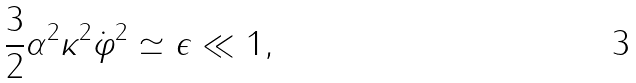<formula> <loc_0><loc_0><loc_500><loc_500>\frac { 3 } { 2 } \alpha ^ { 2 } \kappa ^ { 2 } \dot { \varphi } ^ { 2 } \simeq \epsilon \ll 1 ,</formula> 